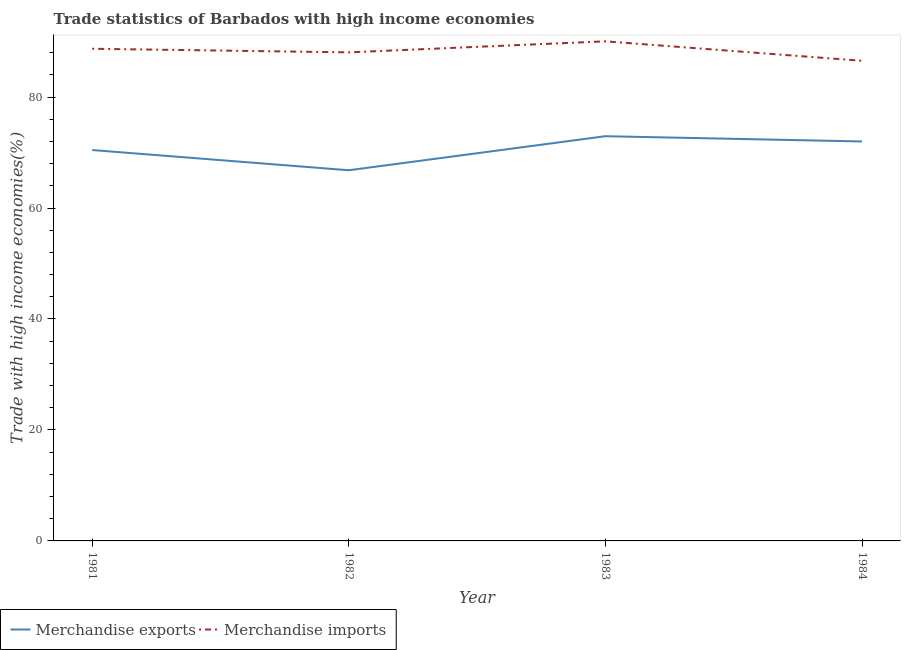How many different coloured lines are there?
Offer a terse response. 2. What is the merchandise exports in 1981?
Give a very brief answer. 70.45. Across all years, what is the maximum merchandise imports?
Offer a very short reply. 90.04. Across all years, what is the minimum merchandise imports?
Give a very brief answer. 86.53. In which year was the merchandise imports minimum?
Ensure brevity in your answer.  1984. What is the total merchandise exports in the graph?
Keep it short and to the point. 282.19. What is the difference between the merchandise exports in 1983 and that in 1984?
Offer a terse response. 0.95. What is the difference between the merchandise imports in 1982 and the merchandise exports in 1983?
Ensure brevity in your answer.  15.11. What is the average merchandise imports per year?
Provide a succinct answer. 88.33. In the year 1984, what is the difference between the merchandise imports and merchandise exports?
Ensure brevity in your answer.  14.54. What is the ratio of the merchandise imports in 1981 to that in 1982?
Provide a short and direct response. 1.01. Is the merchandise imports in 1982 less than that in 1984?
Your response must be concise. No. What is the difference between the highest and the second highest merchandise exports?
Your answer should be very brief. 0.95. What is the difference between the highest and the lowest merchandise exports?
Make the answer very short. 6.14. Is the merchandise exports strictly less than the merchandise imports over the years?
Offer a terse response. Yes. How many years are there in the graph?
Keep it short and to the point. 4. Does the graph contain grids?
Offer a very short reply. No. Where does the legend appear in the graph?
Your response must be concise. Bottom left. What is the title of the graph?
Provide a short and direct response. Trade statistics of Barbados with high income economies. What is the label or title of the X-axis?
Provide a succinct answer. Year. What is the label or title of the Y-axis?
Offer a terse response. Trade with high income economies(%). What is the Trade with high income economies(%) in Merchandise exports in 1981?
Provide a succinct answer. 70.45. What is the Trade with high income economies(%) in Merchandise imports in 1981?
Provide a succinct answer. 88.7. What is the Trade with high income economies(%) in Merchandise exports in 1982?
Give a very brief answer. 66.81. What is the Trade with high income economies(%) in Merchandise imports in 1982?
Offer a terse response. 88.06. What is the Trade with high income economies(%) of Merchandise exports in 1983?
Make the answer very short. 72.94. What is the Trade with high income economies(%) of Merchandise imports in 1983?
Offer a very short reply. 90.04. What is the Trade with high income economies(%) in Merchandise exports in 1984?
Provide a succinct answer. 71.99. What is the Trade with high income economies(%) in Merchandise imports in 1984?
Offer a terse response. 86.53. Across all years, what is the maximum Trade with high income economies(%) of Merchandise exports?
Your answer should be very brief. 72.94. Across all years, what is the maximum Trade with high income economies(%) of Merchandise imports?
Your answer should be very brief. 90.04. Across all years, what is the minimum Trade with high income economies(%) of Merchandise exports?
Offer a very short reply. 66.81. Across all years, what is the minimum Trade with high income economies(%) in Merchandise imports?
Ensure brevity in your answer.  86.53. What is the total Trade with high income economies(%) of Merchandise exports in the graph?
Your response must be concise. 282.19. What is the total Trade with high income economies(%) of Merchandise imports in the graph?
Your answer should be compact. 353.34. What is the difference between the Trade with high income economies(%) of Merchandise exports in 1981 and that in 1982?
Make the answer very short. 3.64. What is the difference between the Trade with high income economies(%) in Merchandise imports in 1981 and that in 1982?
Give a very brief answer. 0.65. What is the difference between the Trade with high income economies(%) in Merchandise exports in 1981 and that in 1983?
Your response must be concise. -2.49. What is the difference between the Trade with high income economies(%) of Merchandise imports in 1981 and that in 1983?
Ensure brevity in your answer.  -1.34. What is the difference between the Trade with high income economies(%) of Merchandise exports in 1981 and that in 1984?
Your answer should be compact. -1.54. What is the difference between the Trade with high income economies(%) of Merchandise imports in 1981 and that in 1984?
Provide a succinct answer. 2.17. What is the difference between the Trade with high income economies(%) of Merchandise exports in 1982 and that in 1983?
Your answer should be compact. -6.14. What is the difference between the Trade with high income economies(%) of Merchandise imports in 1982 and that in 1983?
Provide a short and direct response. -1.99. What is the difference between the Trade with high income economies(%) in Merchandise exports in 1982 and that in 1984?
Give a very brief answer. -5.19. What is the difference between the Trade with high income economies(%) in Merchandise imports in 1982 and that in 1984?
Your answer should be compact. 1.52. What is the difference between the Trade with high income economies(%) of Merchandise exports in 1983 and that in 1984?
Make the answer very short. 0.95. What is the difference between the Trade with high income economies(%) in Merchandise imports in 1983 and that in 1984?
Your answer should be very brief. 3.51. What is the difference between the Trade with high income economies(%) of Merchandise exports in 1981 and the Trade with high income economies(%) of Merchandise imports in 1982?
Offer a very short reply. -17.61. What is the difference between the Trade with high income economies(%) of Merchandise exports in 1981 and the Trade with high income economies(%) of Merchandise imports in 1983?
Offer a very short reply. -19.59. What is the difference between the Trade with high income economies(%) in Merchandise exports in 1981 and the Trade with high income economies(%) in Merchandise imports in 1984?
Provide a short and direct response. -16.08. What is the difference between the Trade with high income economies(%) in Merchandise exports in 1982 and the Trade with high income economies(%) in Merchandise imports in 1983?
Give a very brief answer. -23.24. What is the difference between the Trade with high income economies(%) in Merchandise exports in 1982 and the Trade with high income economies(%) in Merchandise imports in 1984?
Ensure brevity in your answer.  -19.73. What is the difference between the Trade with high income economies(%) in Merchandise exports in 1983 and the Trade with high income economies(%) in Merchandise imports in 1984?
Offer a terse response. -13.59. What is the average Trade with high income economies(%) of Merchandise exports per year?
Your answer should be very brief. 70.55. What is the average Trade with high income economies(%) of Merchandise imports per year?
Your answer should be very brief. 88.33. In the year 1981, what is the difference between the Trade with high income economies(%) in Merchandise exports and Trade with high income economies(%) in Merchandise imports?
Make the answer very short. -18.25. In the year 1982, what is the difference between the Trade with high income economies(%) in Merchandise exports and Trade with high income economies(%) in Merchandise imports?
Your answer should be very brief. -21.25. In the year 1983, what is the difference between the Trade with high income economies(%) of Merchandise exports and Trade with high income economies(%) of Merchandise imports?
Your answer should be compact. -17.1. In the year 1984, what is the difference between the Trade with high income economies(%) of Merchandise exports and Trade with high income economies(%) of Merchandise imports?
Provide a short and direct response. -14.54. What is the ratio of the Trade with high income economies(%) in Merchandise exports in 1981 to that in 1982?
Ensure brevity in your answer.  1.05. What is the ratio of the Trade with high income economies(%) in Merchandise imports in 1981 to that in 1982?
Offer a terse response. 1.01. What is the ratio of the Trade with high income economies(%) of Merchandise exports in 1981 to that in 1983?
Ensure brevity in your answer.  0.97. What is the ratio of the Trade with high income economies(%) in Merchandise imports in 1981 to that in 1983?
Your answer should be compact. 0.99. What is the ratio of the Trade with high income economies(%) of Merchandise exports in 1981 to that in 1984?
Your answer should be compact. 0.98. What is the ratio of the Trade with high income economies(%) in Merchandise imports in 1981 to that in 1984?
Give a very brief answer. 1.03. What is the ratio of the Trade with high income economies(%) in Merchandise exports in 1982 to that in 1983?
Offer a terse response. 0.92. What is the ratio of the Trade with high income economies(%) in Merchandise imports in 1982 to that in 1983?
Keep it short and to the point. 0.98. What is the ratio of the Trade with high income economies(%) of Merchandise exports in 1982 to that in 1984?
Make the answer very short. 0.93. What is the ratio of the Trade with high income economies(%) of Merchandise imports in 1982 to that in 1984?
Your answer should be compact. 1.02. What is the ratio of the Trade with high income economies(%) of Merchandise exports in 1983 to that in 1984?
Your answer should be compact. 1.01. What is the ratio of the Trade with high income economies(%) of Merchandise imports in 1983 to that in 1984?
Offer a terse response. 1.04. What is the difference between the highest and the second highest Trade with high income economies(%) in Merchandise exports?
Make the answer very short. 0.95. What is the difference between the highest and the second highest Trade with high income economies(%) of Merchandise imports?
Your answer should be very brief. 1.34. What is the difference between the highest and the lowest Trade with high income economies(%) in Merchandise exports?
Give a very brief answer. 6.14. What is the difference between the highest and the lowest Trade with high income economies(%) of Merchandise imports?
Ensure brevity in your answer.  3.51. 